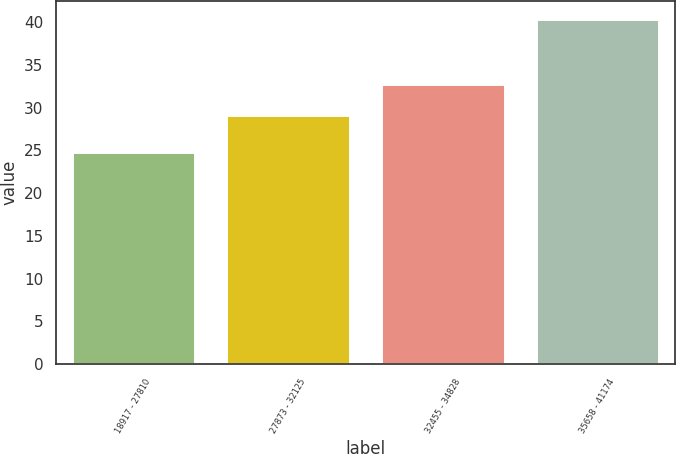Convert chart. <chart><loc_0><loc_0><loc_500><loc_500><bar_chart><fcel>18917 - 27810<fcel>27873 - 32125<fcel>32455 - 34828<fcel>35658 - 41174<nl><fcel>24.87<fcel>29.1<fcel>32.76<fcel>40.43<nl></chart> 